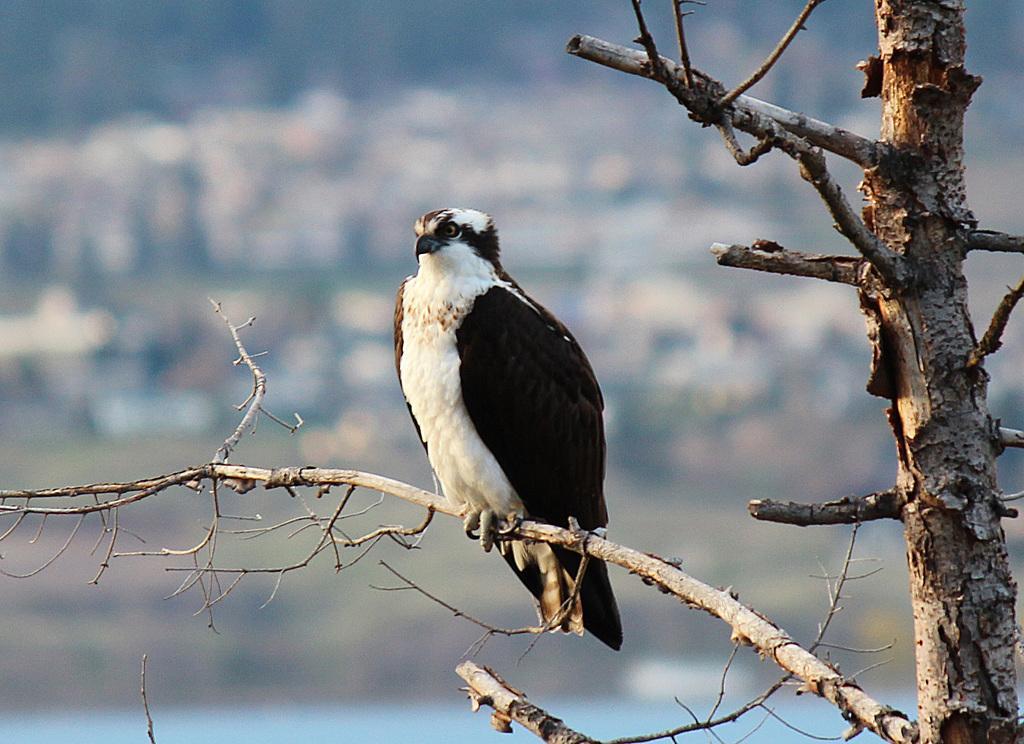Please provide a concise description of this image. In this picture we can see an eagle, who is standing on the tree branch. 